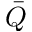Convert formula to latex. <formula><loc_0><loc_0><loc_500><loc_500>\bar { Q }</formula> 